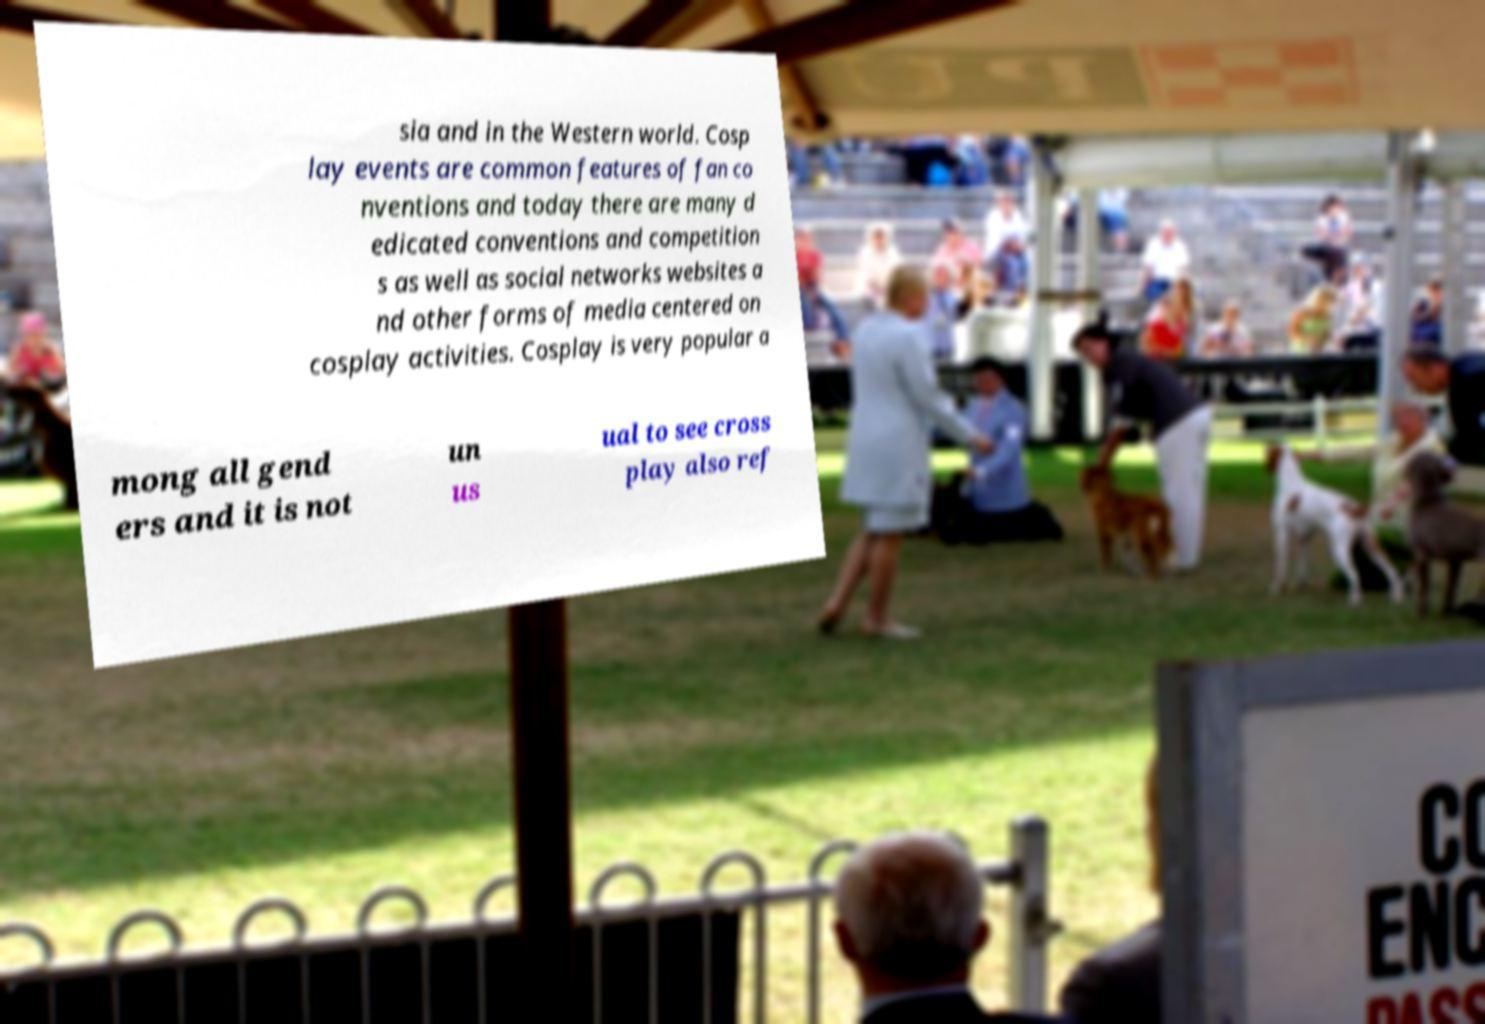I need the written content from this picture converted into text. Can you do that? sia and in the Western world. Cosp lay events are common features of fan co nventions and today there are many d edicated conventions and competition s as well as social networks websites a nd other forms of media centered on cosplay activities. Cosplay is very popular a mong all gend ers and it is not un us ual to see cross play also ref 